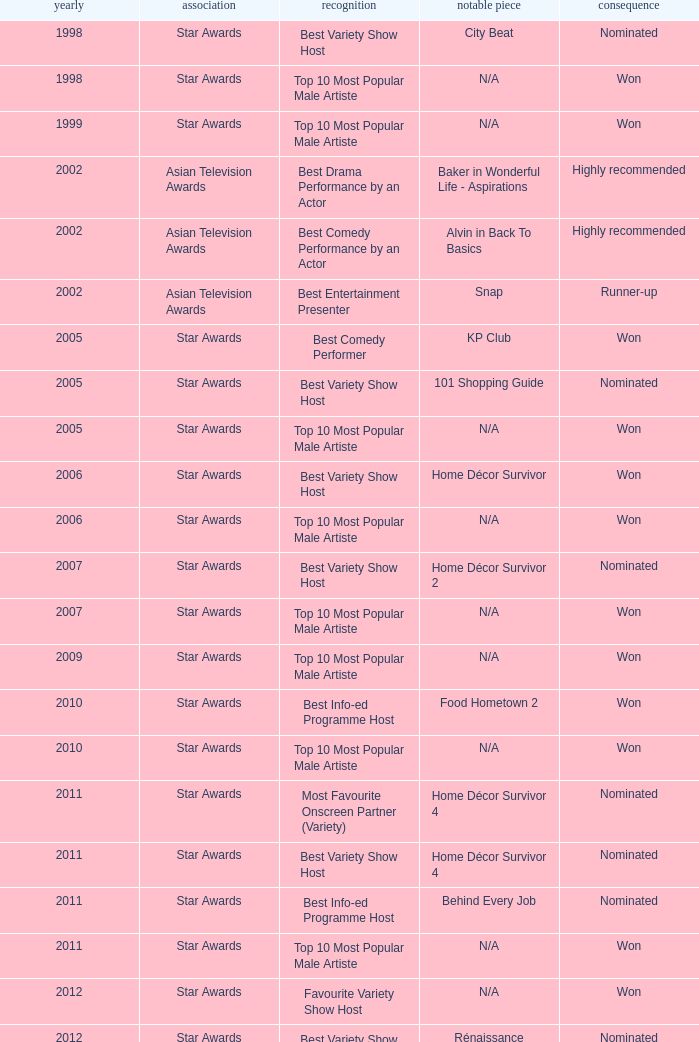What is the organisation in 2011 that was nominated and the award of best info-ed programme host? Star Awards. 